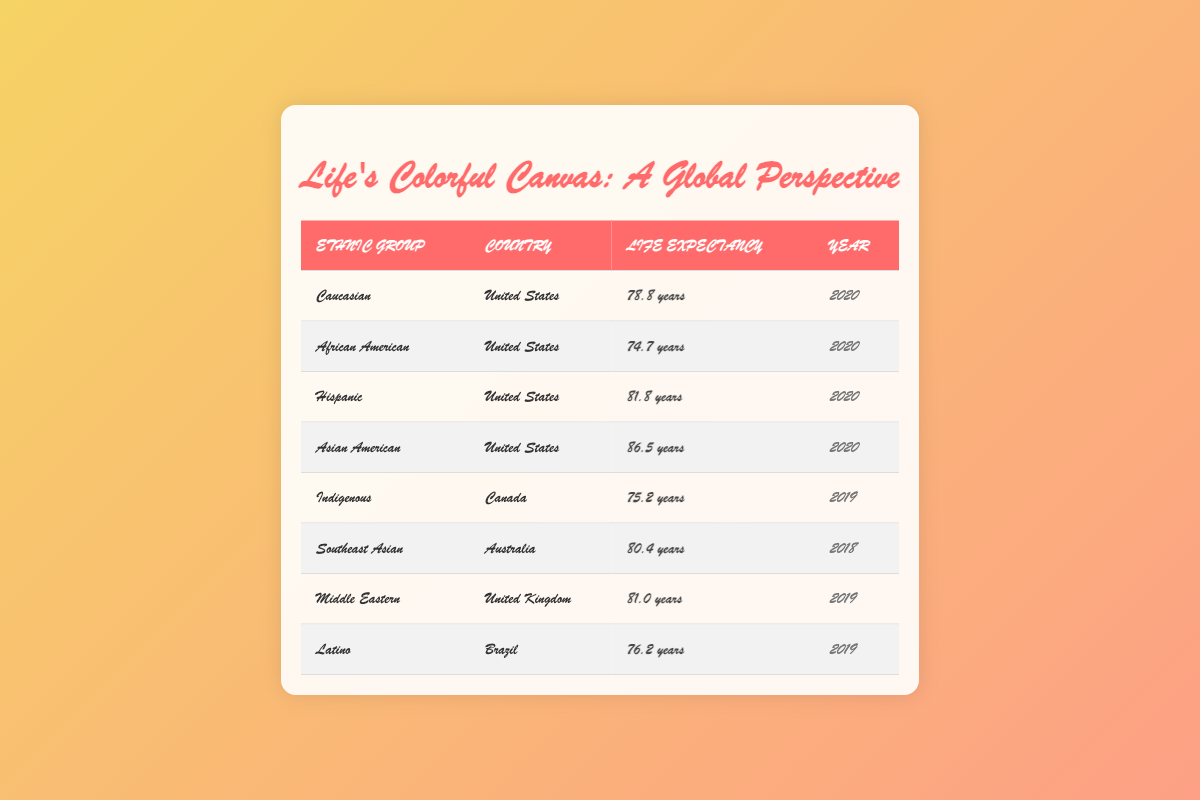What is the average life expectancy for Caucasians in the United States? The table indicates that the average life expectancy for Caucasians in the United States is 78.8 years.
Answer: 78.8 years Is the life expectancy for Asian Americans higher than that of Hispanic people in the United States? The table shows that Asian Americans have an average life expectancy of 86.5 years, while Hispanics have an average of 81.8 years. Since 86.5 is greater than 81.8, it confirms that Asian Americans have a higher life expectancy.
Answer: Yes What is the difference in life expectancy between African Americans and Hispanics in the United States? The average life expectancy for African Americans is 74.7 years, and for Hispanics it is 81.8 years. To find the difference, subtract the African American average from the Hispanic average: 81.8 - 74.7 = 7.1 years.
Answer: 7.1 years Which ethnic group has the highest life expectancy, and what is that value? By comparing the values in the table, Asian Americans have the highest average life expectancy at 86.5 years.
Answer: 86.5 years Is the life expectancy of Indigenous people in Canada higher or lower than that of Latino people in Brazil? Indigenous people's average life expectancy is 75.2 years, while Latino people's is 76.2 years. Since 75.2 is less than 76.2, it shows that Indigenous people's life expectancy is lower.
Answer: Lower What is the average life expectancy for all ethnic groups listed in the United States? To calculate the average, sum the life expectancies of Caucasian (78.8), African American (74.7), Hispanic (81.8), and Asian American (86.5): 78.8 + 74.7 + 81.8 + 86.5 = 322. The number of groups is 4, so the average is 322 / 4 = 80.5 years.
Answer: 80.5 years Does the average life expectancy for Southeast Asians in Australia exceed 80 years? The table shows that the average life expectancy for Southeast Asians is 80.4 years, which is greater than 80 years, confirming the statement is true.
Answer: Yes Which ethnic group in the table has the lowest life expectancy, and what is that expectancy? Analyzing the table, African Americans have the lowest life expectancy at 74.7 years compared to the other groups listed.
Answer: 74.7 years What is the average life expectancy of ethnic groups in countries outside the United States? The ethnic groups outside the United States are Indigenous in Canada (75.2 years), Southeast Asian in Australia (80.4 years), and Middle Eastern in the United Kingdom (81.0 years). To calculate the average, sum these values: 75.2 + 80.4 + 81.0 = 236.6. There are 3 groups so the average is 236.6 / 3 = 78.87 years.
Answer: 78.87 years 